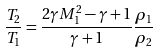<formula> <loc_0><loc_0><loc_500><loc_500>\frac { T _ { 2 } } { T _ { 1 } } = \frac { 2 \gamma M ^ { 2 } _ { 1 } - \gamma + 1 } { \gamma + 1 } \frac { \rho _ { 1 } } { \rho _ { 2 } }</formula> 